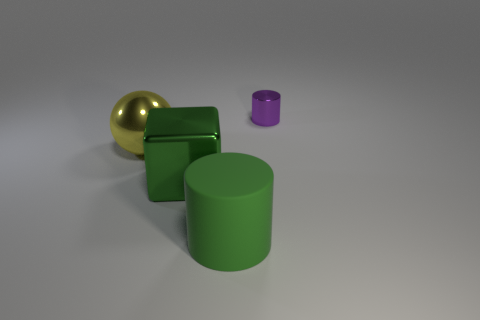Add 3 big metallic blocks. How many objects exist? 7 Subtract all spheres. How many objects are left? 3 Add 1 objects. How many objects exist? 5 Subtract 0 brown cylinders. How many objects are left? 4 Subtract all large purple matte balls. Subtract all green matte things. How many objects are left? 3 Add 3 large things. How many large things are left? 6 